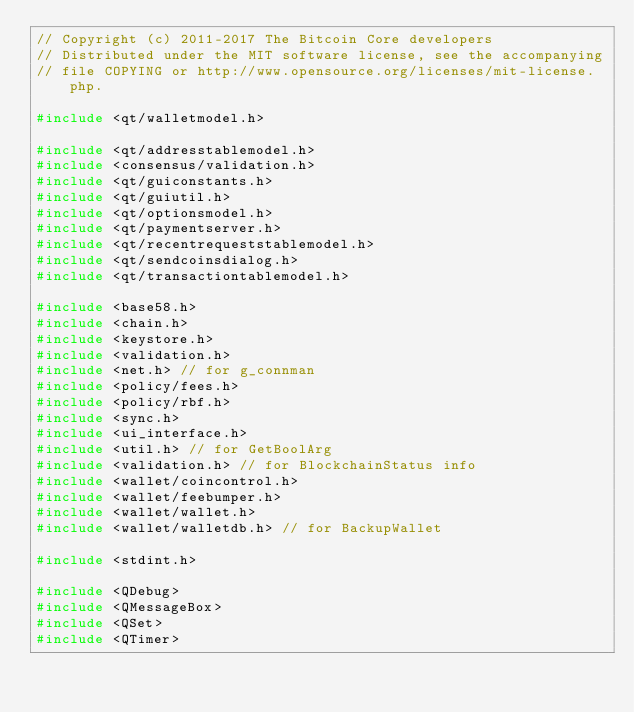<code> <loc_0><loc_0><loc_500><loc_500><_C++_>// Copyright (c) 2011-2017 The Bitcoin Core developers
// Distributed under the MIT software license, see the accompanying
// file COPYING or http://www.opensource.org/licenses/mit-license.php.

#include <qt/walletmodel.h>

#include <qt/addresstablemodel.h>
#include <consensus/validation.h>
#include <qt/guiconstants.h>
#include <qt/guiutil.h>
#include <qt/optionsmodel.h>
#include <qt/paymentserver.h>
#include <qt/recentrequeststablemodel.h>
#include <qt/sendcoinsdialog.h>
#include <qt/transactiontablemodel.h>

#include <base58.h>
#include <chain.h>
#include <keystore.h>
#include <validation.h>
#include <net.h> // for g_connman
#include <policy/fees.h>
#include <policy/rbf.h>
#include <sync.h>
#include <ui_interface.h>
#include <util.h> // for GetBoolArg
#include <validation.h> // for BlockchainStatus info
#include <wallet/coincontrol.h>
#include <wallet/feebumper.h>
#include <wallet/wallet.h>
#include <wallet/walletdb.h> // for BackupWallet

#include <stdint.h>

#include <QDebug>
#include <QMessageBox>
#include <QSet>
#include <QTimer>

</code> 